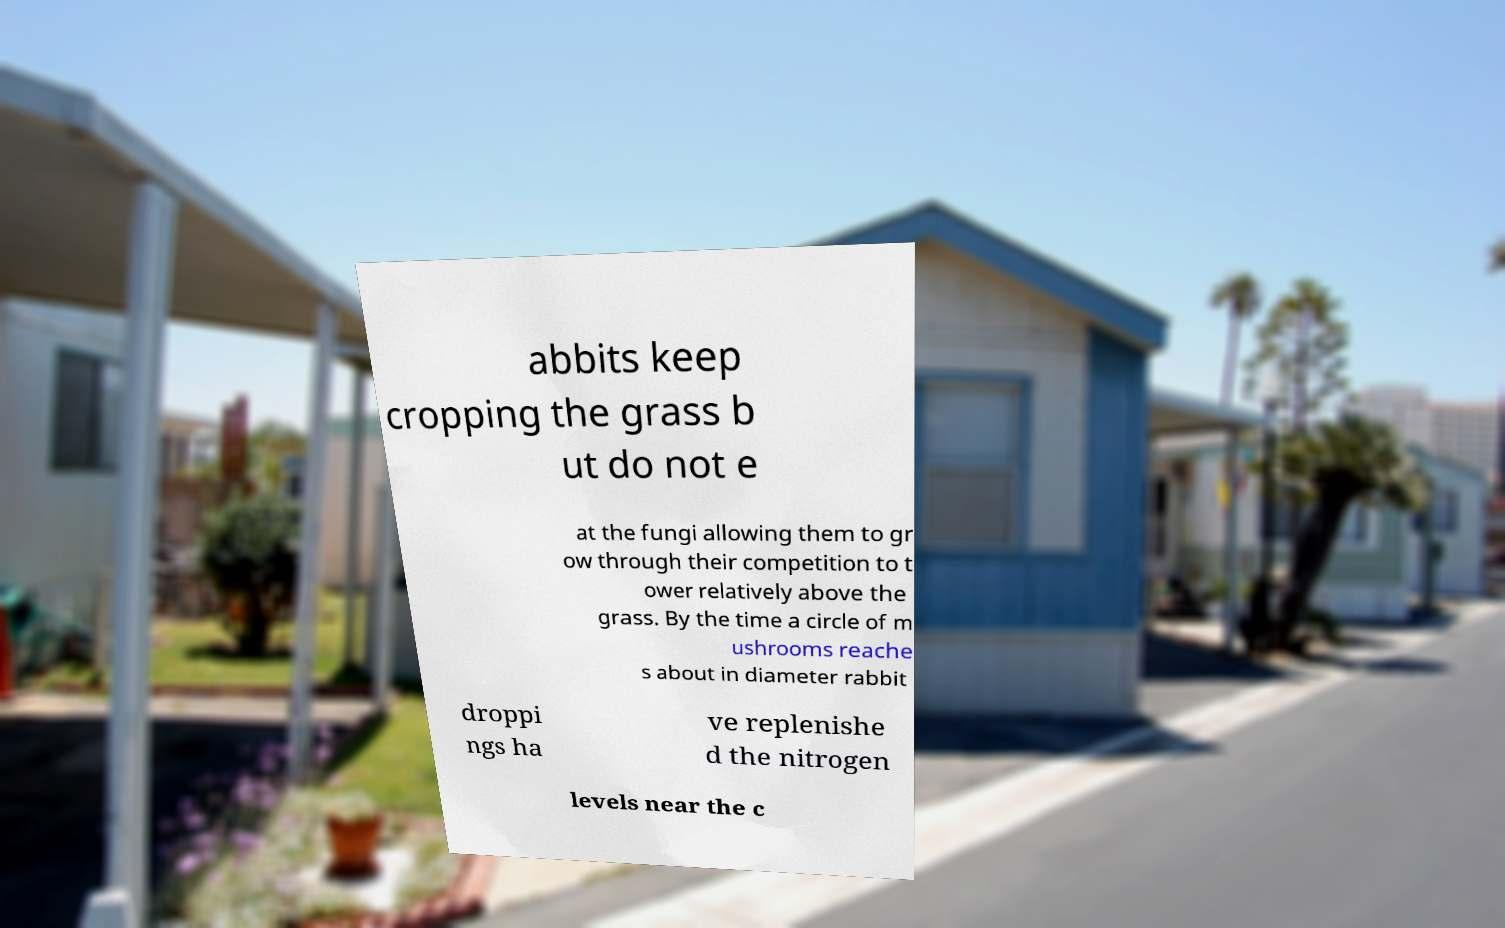I need the written content from this picture converted into text. Can you do that? abbits keep cropping the grass b ut do not e at the fungi allowing them to gr ow through their competition to t ower relatively above the grass. By the time a circle of m ushrooms reache s about in diameter rabbit droppi ngs ha ve replenishe d the nitrogen levels near the c 